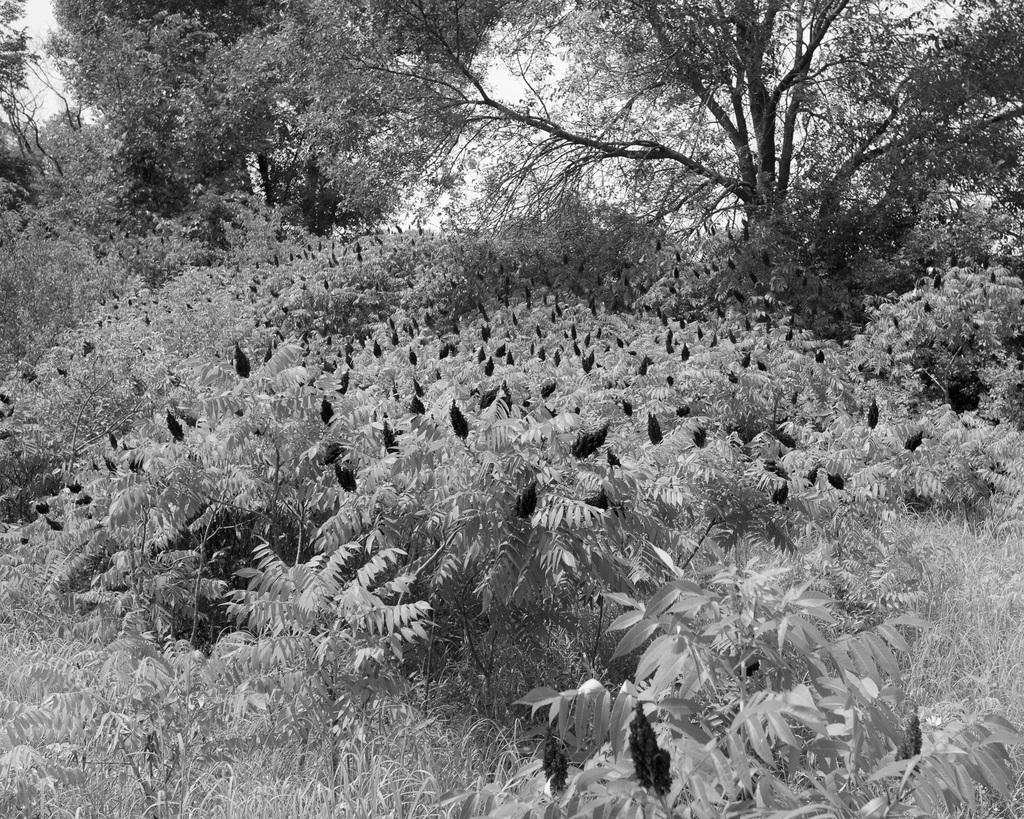What is located in the middle of the image? There are bushes in the middle of the image. What can be seen in the background of the image? There are trees in the background of the image. How is the image presented in terms of color? The image is in black and white color. Where is the harbor located in the image? There is no harbor present in the image. What type of curtain can be seen hanging from the trees in the image? There are no curtains present in the image; it features bushes and trees. 